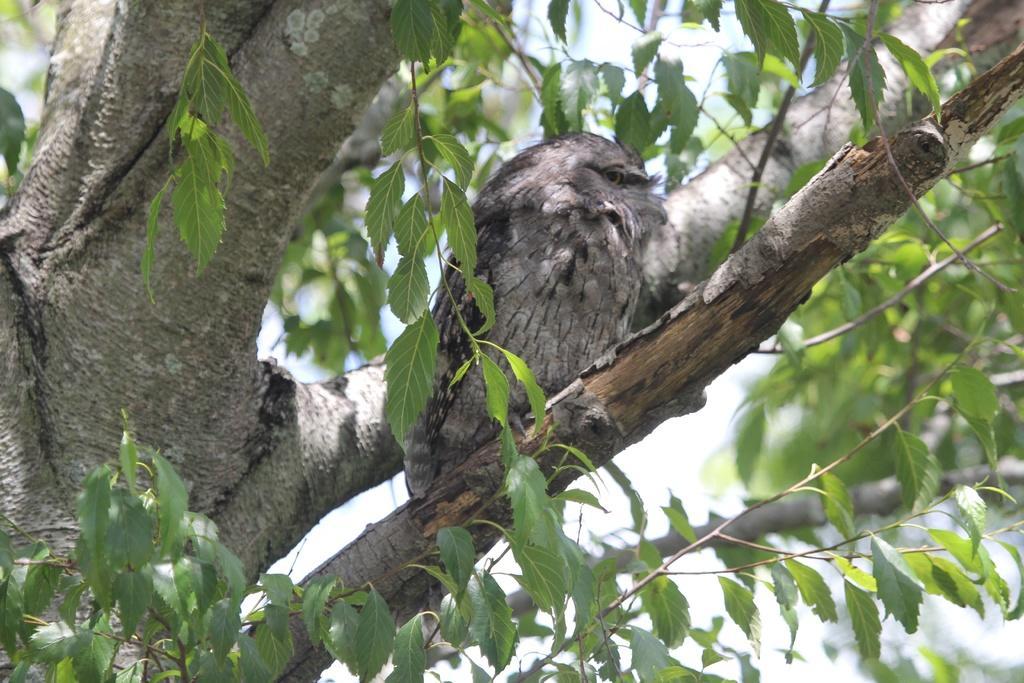How would you summarize this image in a sentence or two? Here we can see a bird on the branch. There are trees. In the background there is sky. 